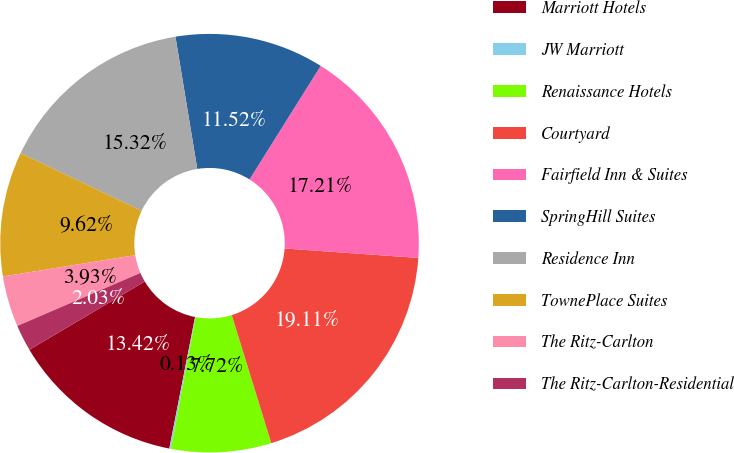Convert chart to OTSL. <chart><loc_0><loc_0><loc_500><loc_500><pie_chart><fcel>Marriott Hotels<fcel>JW Marriott<fcel>Renaissance Hotels<fcel>Courtyard<fcel>Fairfield Inn & Suites<fcel>SpringHill Suites<fcel>Residence Inn<fcel>TownePlace Suites<fcel>The Ritz-Carlton<fcel>The Ritz-Carlton-Residential<nl><fcel>13.42%<fcel>0.13%<fcel>7.72%<fcel>19.11%<fcel>17.21%<fcel>11.52%<fcel>15.32%<fcel>9.62%<fcel>3.93%<fcel>2.03%<nl></chart> 